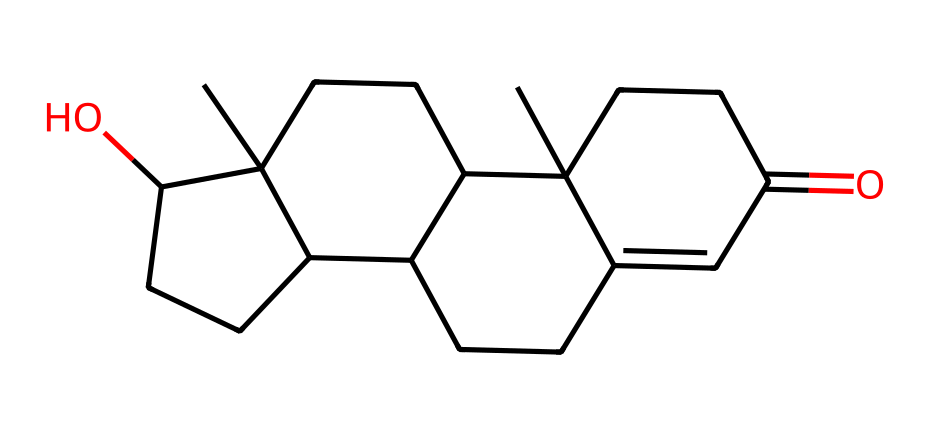What is the molecular formula of testosterone? By analyzing the provided SMILES representation, we can determine the molecular formula. The formula is derived from counting the total number of carbon (C), hydrogen (H), and oxygen (O) atoms present in the structure. In this case, there are 19 carbon atoms, 28 hydrogen atoms, and 2 oxygen atoms.
Answer: C19H28O2 How many rings are present in the structure? The SMILES notation indicates that there are multiple ring structures by the presence of numbers denoting ring atoms. By counting these numbers and analyzing the connections within the structure, we can identify a total of four rings.
Answer: 4 What type of functional groups are present in testosterone? By examining the structure for specific functionalities indicated in the SMILES, we can identify the presence of alcohol (−OH) and carbonyl (C=O) groups. The hydroxyl part can be observed from the "O" after the "C1", and the carbonyl can be determined due to the "CC(=O)".
Answer: hydroxyl and carbonyl Which carbon atom is part of a carbonyl functional group? From the SMILES, we can see that the carbon atom connected by a double bond to an oxygen (C=O) defines the carbonyl function. By tracing the structure, that carbon is located in the segment labeled as CCC(=O).
Answer: C9 What type of hydrocarbon structure does testosterone represent? Testosterone, based on its cyclopentane and cyclohexane rings, represents a steroid structure, which consists of multiple fused rings categorized statistically as a type of hydrocarbon. This classification reflects its origin and structure as a compound of multiple interconnected cyclic aliphatic carbons.
Answer: steroid What is the significance of the hydroxyl group in testosterone? The hydroxyl group adds polarity to the molecule, which can influence the solubility properties and biological activity of testosterone. In hormones like testosterone, a hydroxyl group is crucial for interaction with receptor proteins in target tissues.
Answer: enhances solubility and activity 